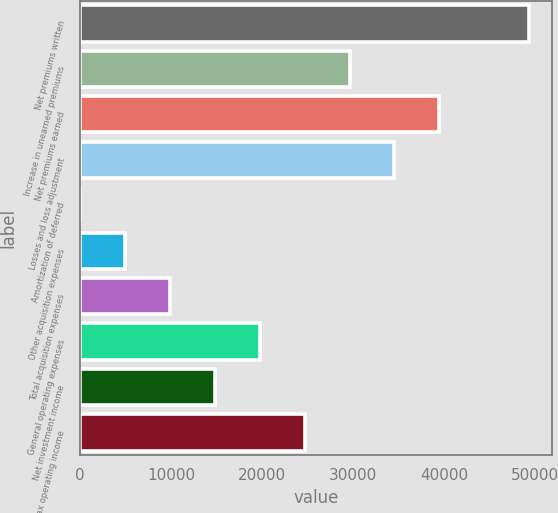Convert chart. <chart><loc_0><loc_0><loc_500><loc_500><bar_chart><fcel>Net premiums written<fcel>Increase in unearned premiums<fcel>Net premiums earned<fcel>Losses and loss adjustment<fcel>Amortization of deferred<fcel>Other acquisition expenses<fcel>Total acquisition expenses<fcel>General operating expenses<fcel>Net investment income<fcel>Pre-tax operating income<nl><fcel>49356<fcel>29621.6<fcel>39488.8<fcel>34555.2<fcel>20<fcel>4953.6<fcel>9887.2<fcel>19754.4<fcel>14820.8<fcel>24688<nl></chart> 